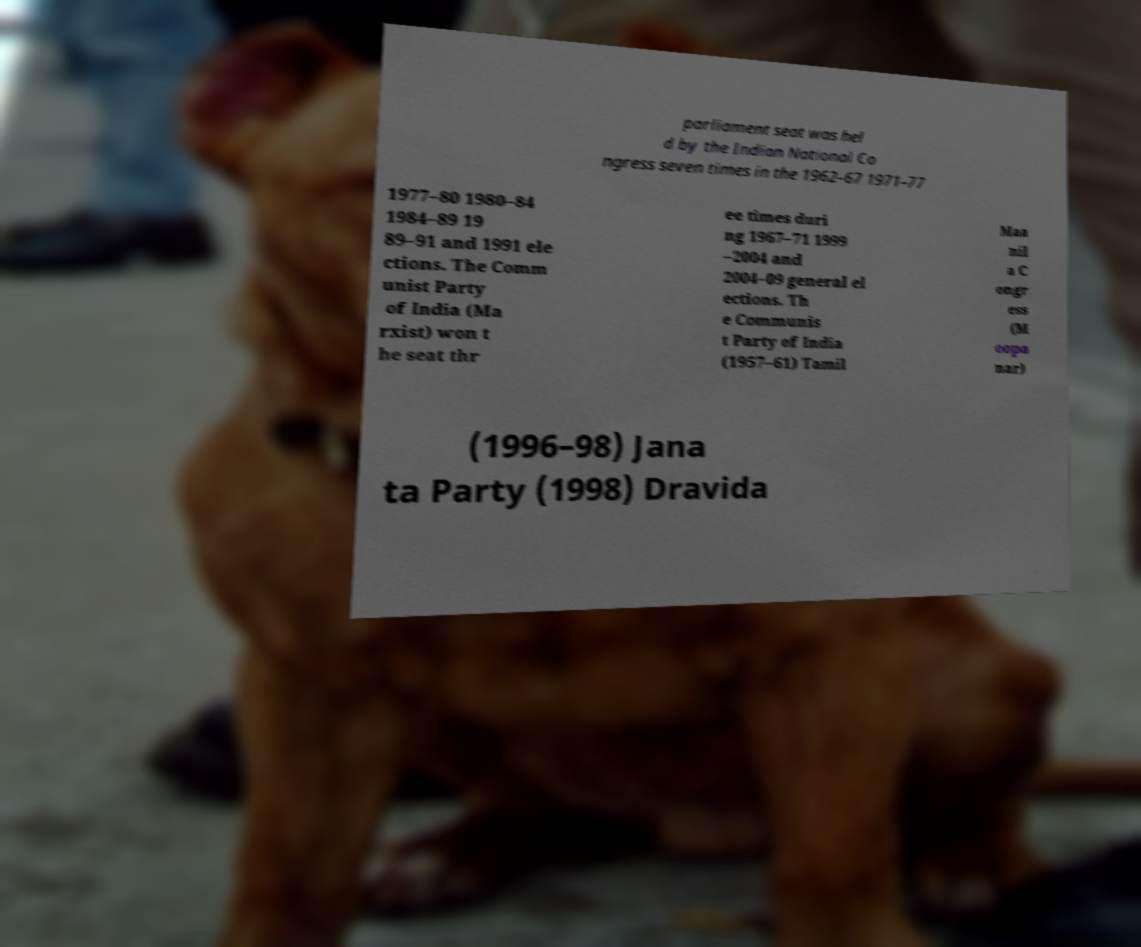Could you extract and type out the text from this image? parliament seat was hel d by the Indian National Co ngress seven times in the 1962–67 1971–77 1977–80 1980–84 1984–89 19 89–91 and 1991 ele ctions. The Comm unist Party of India (Ma rxist) won t he seat thr ee times duri ng 1967–71 1999 –2004 and 2004–09 general el ections. Th e Communis t Party of India (1957–61) Tamil Maa nil a C ongr ess (M oopa nar) (1996–98) Jana ta Party (1998) Dravida 